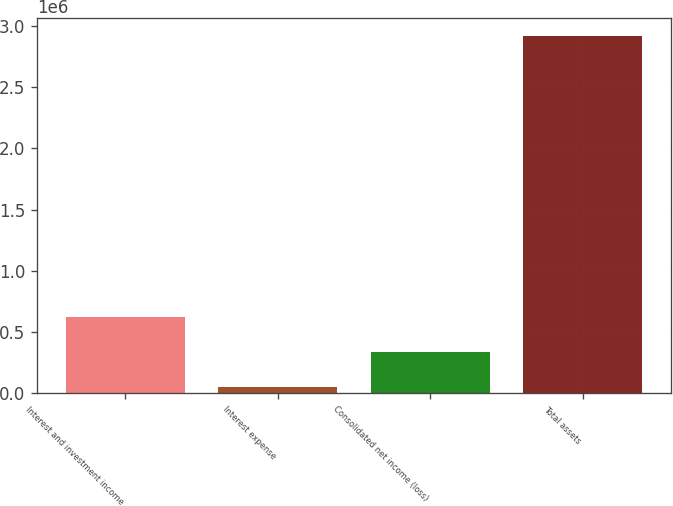Convert chart to OTSL. <chart><loc_0><loc_0><loc_500><loc_500><bar_chart><fcel>Interest and investment income<fcel>Interest expense<fcel>Consolidated net income (loss)<fcel>Total assets<nl><fcel>622861<fcel>48291<fcel>335576<fcel>2.92114e+06<nl></chart> 